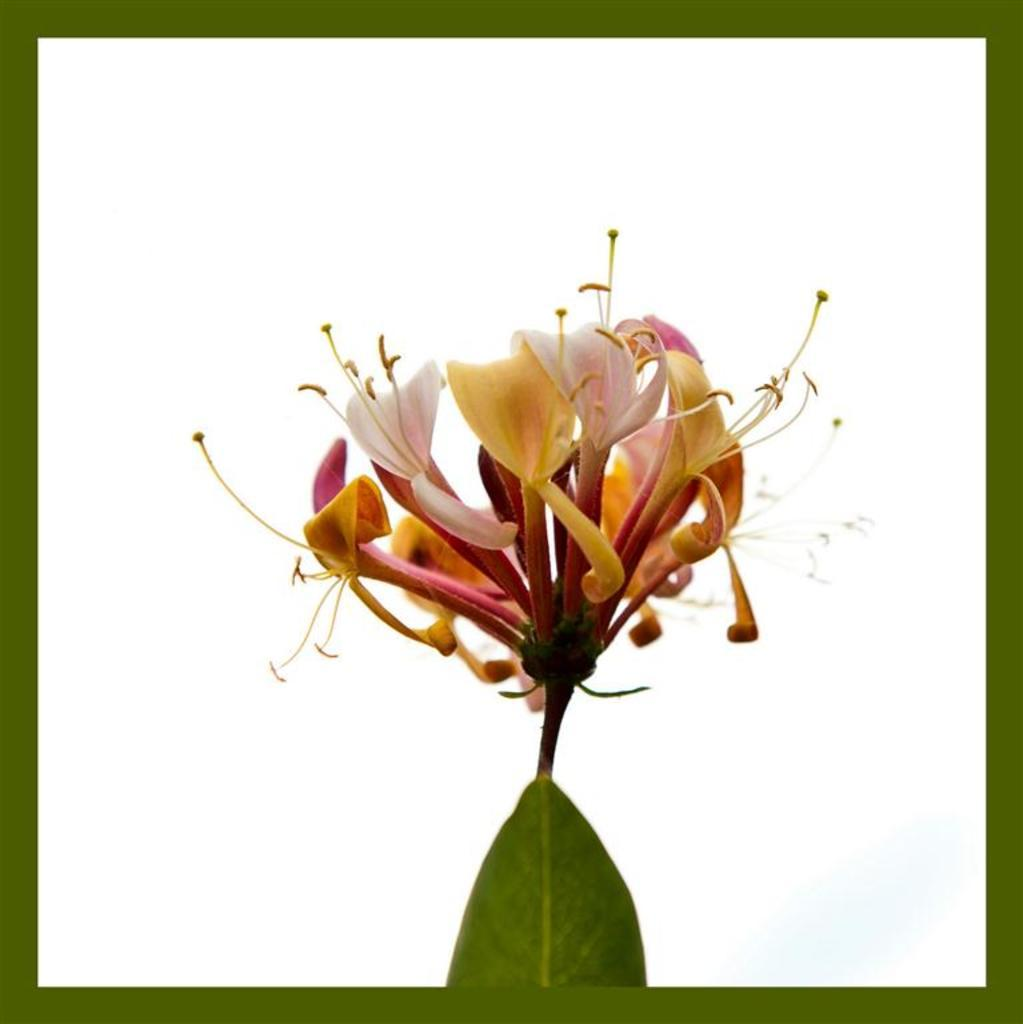What type of plant is visible in the image? There is a flower and a leaf in the image, which suggests a plant is present. Can you describe the leaf in the image? There is a leaf in the image, but no specific details about its shape or size are provided. What hobbies do the stars in the image enjoy? There are no stars present in the image, so it is not possible to determine their hobbies. 